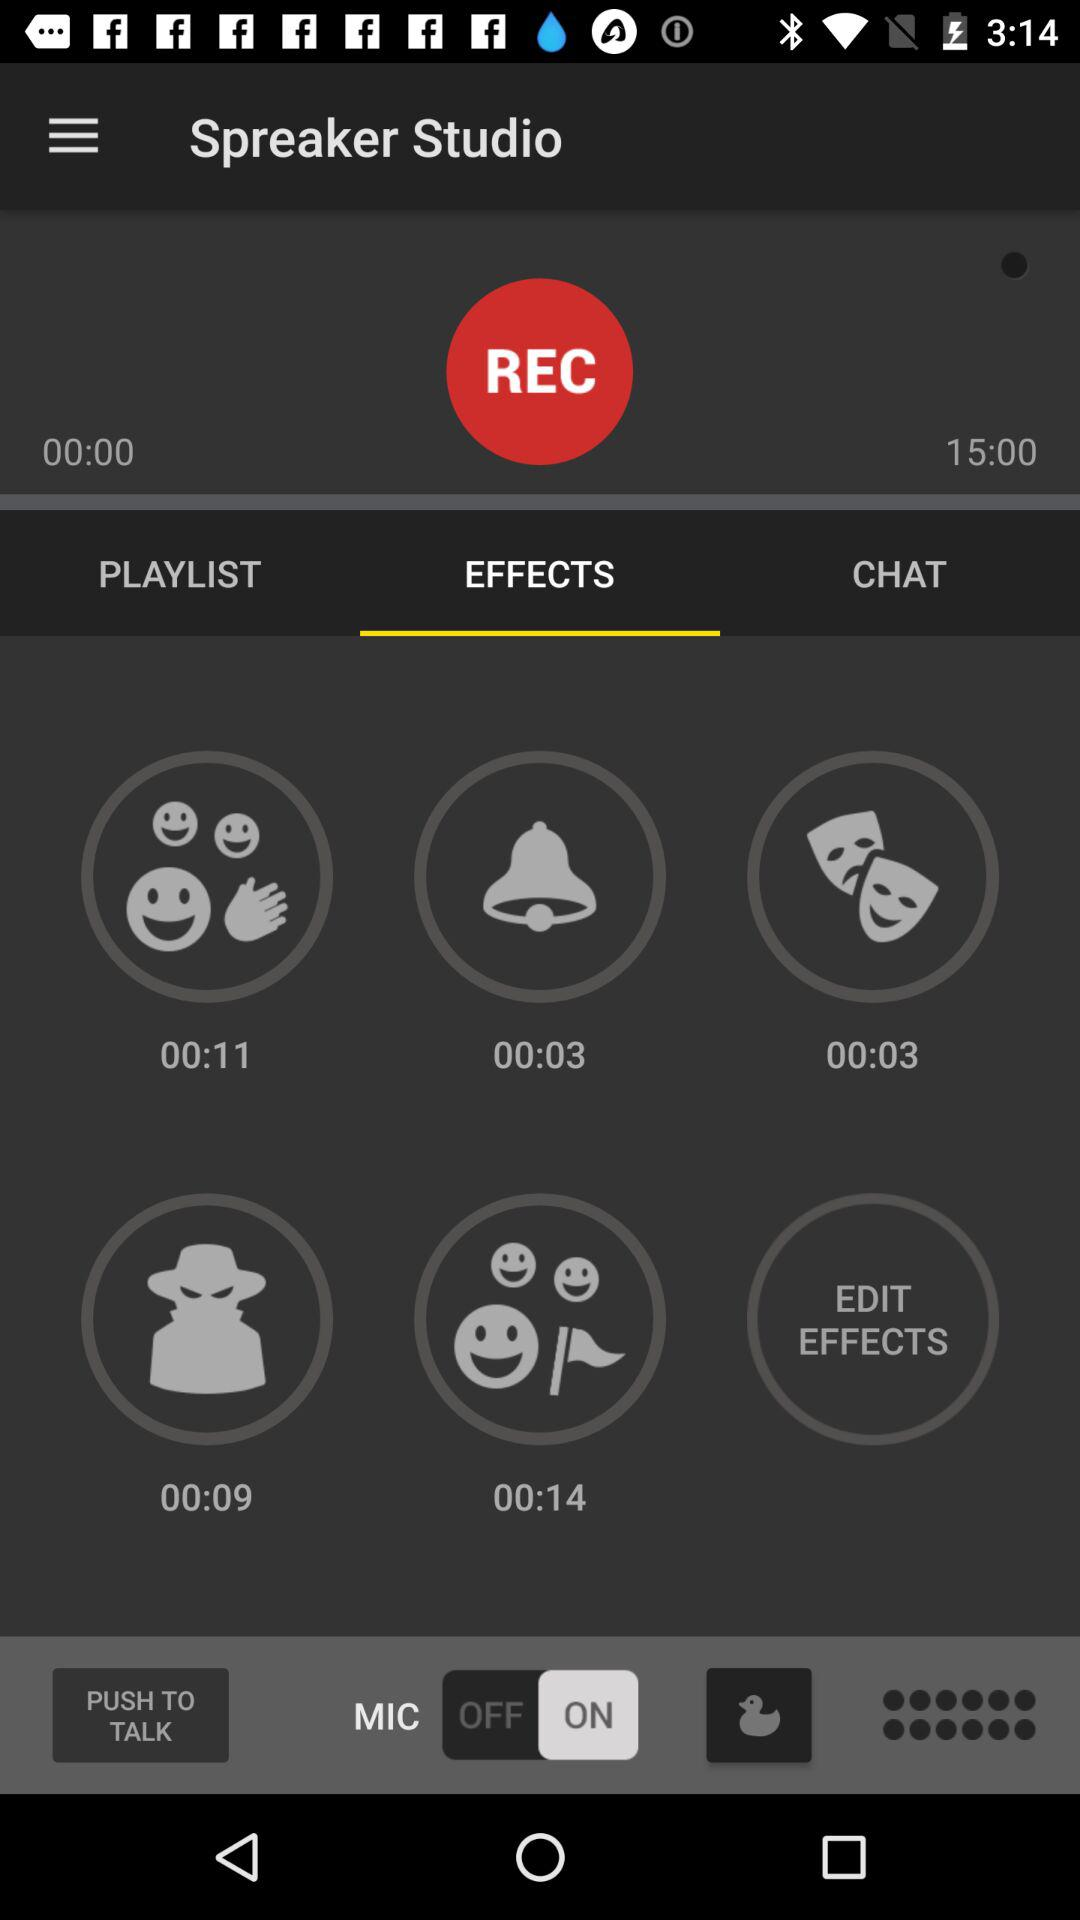How many more seconds are in the second time than the first time?
Answer the question using a single word or phrase. 15 